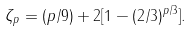<formula> <loc_0><loc_0><loc_500><loc_500>\zeta _ { p } = ( p / 9 ) + 2 [ 1 - ( 2 / 3 ) ^ { p / 3 } ] .</formula> 